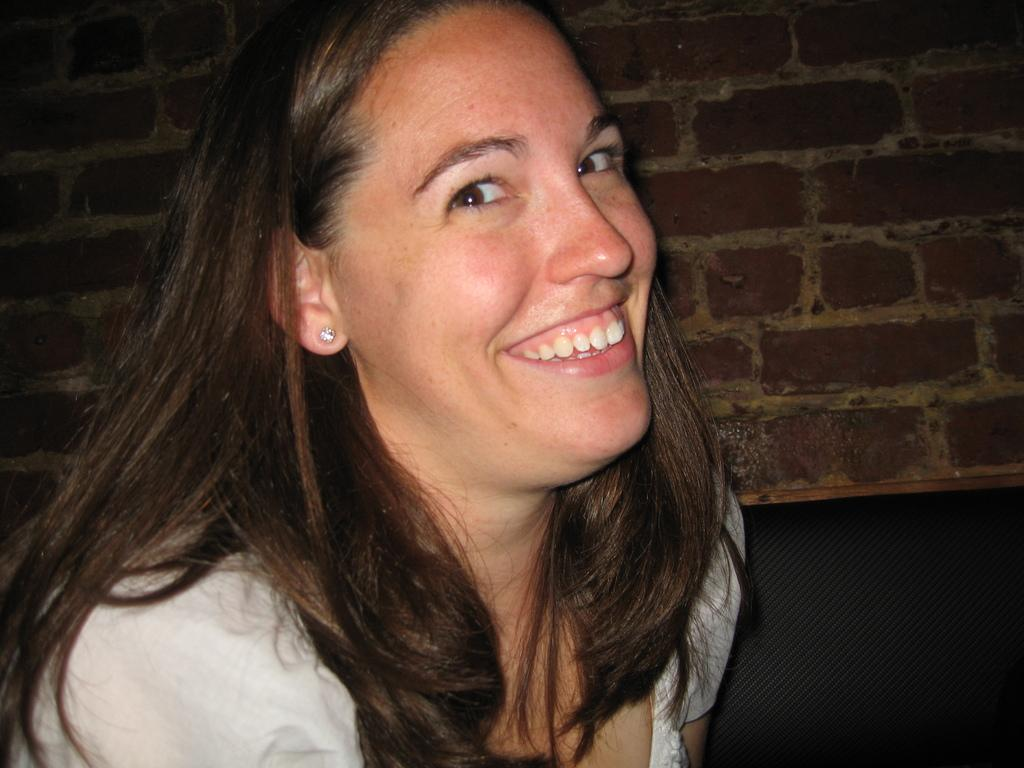Who is the main subject in the image? There is a lady in the center of the image. What can be seen in the background of the image? There is a wall in the background of the image. What type of crime is being committed in the image? There is no crime being committed in the image; it features a lady and a wall in the background. Where is the faucet located in the image? There is no faucet present in the image. 